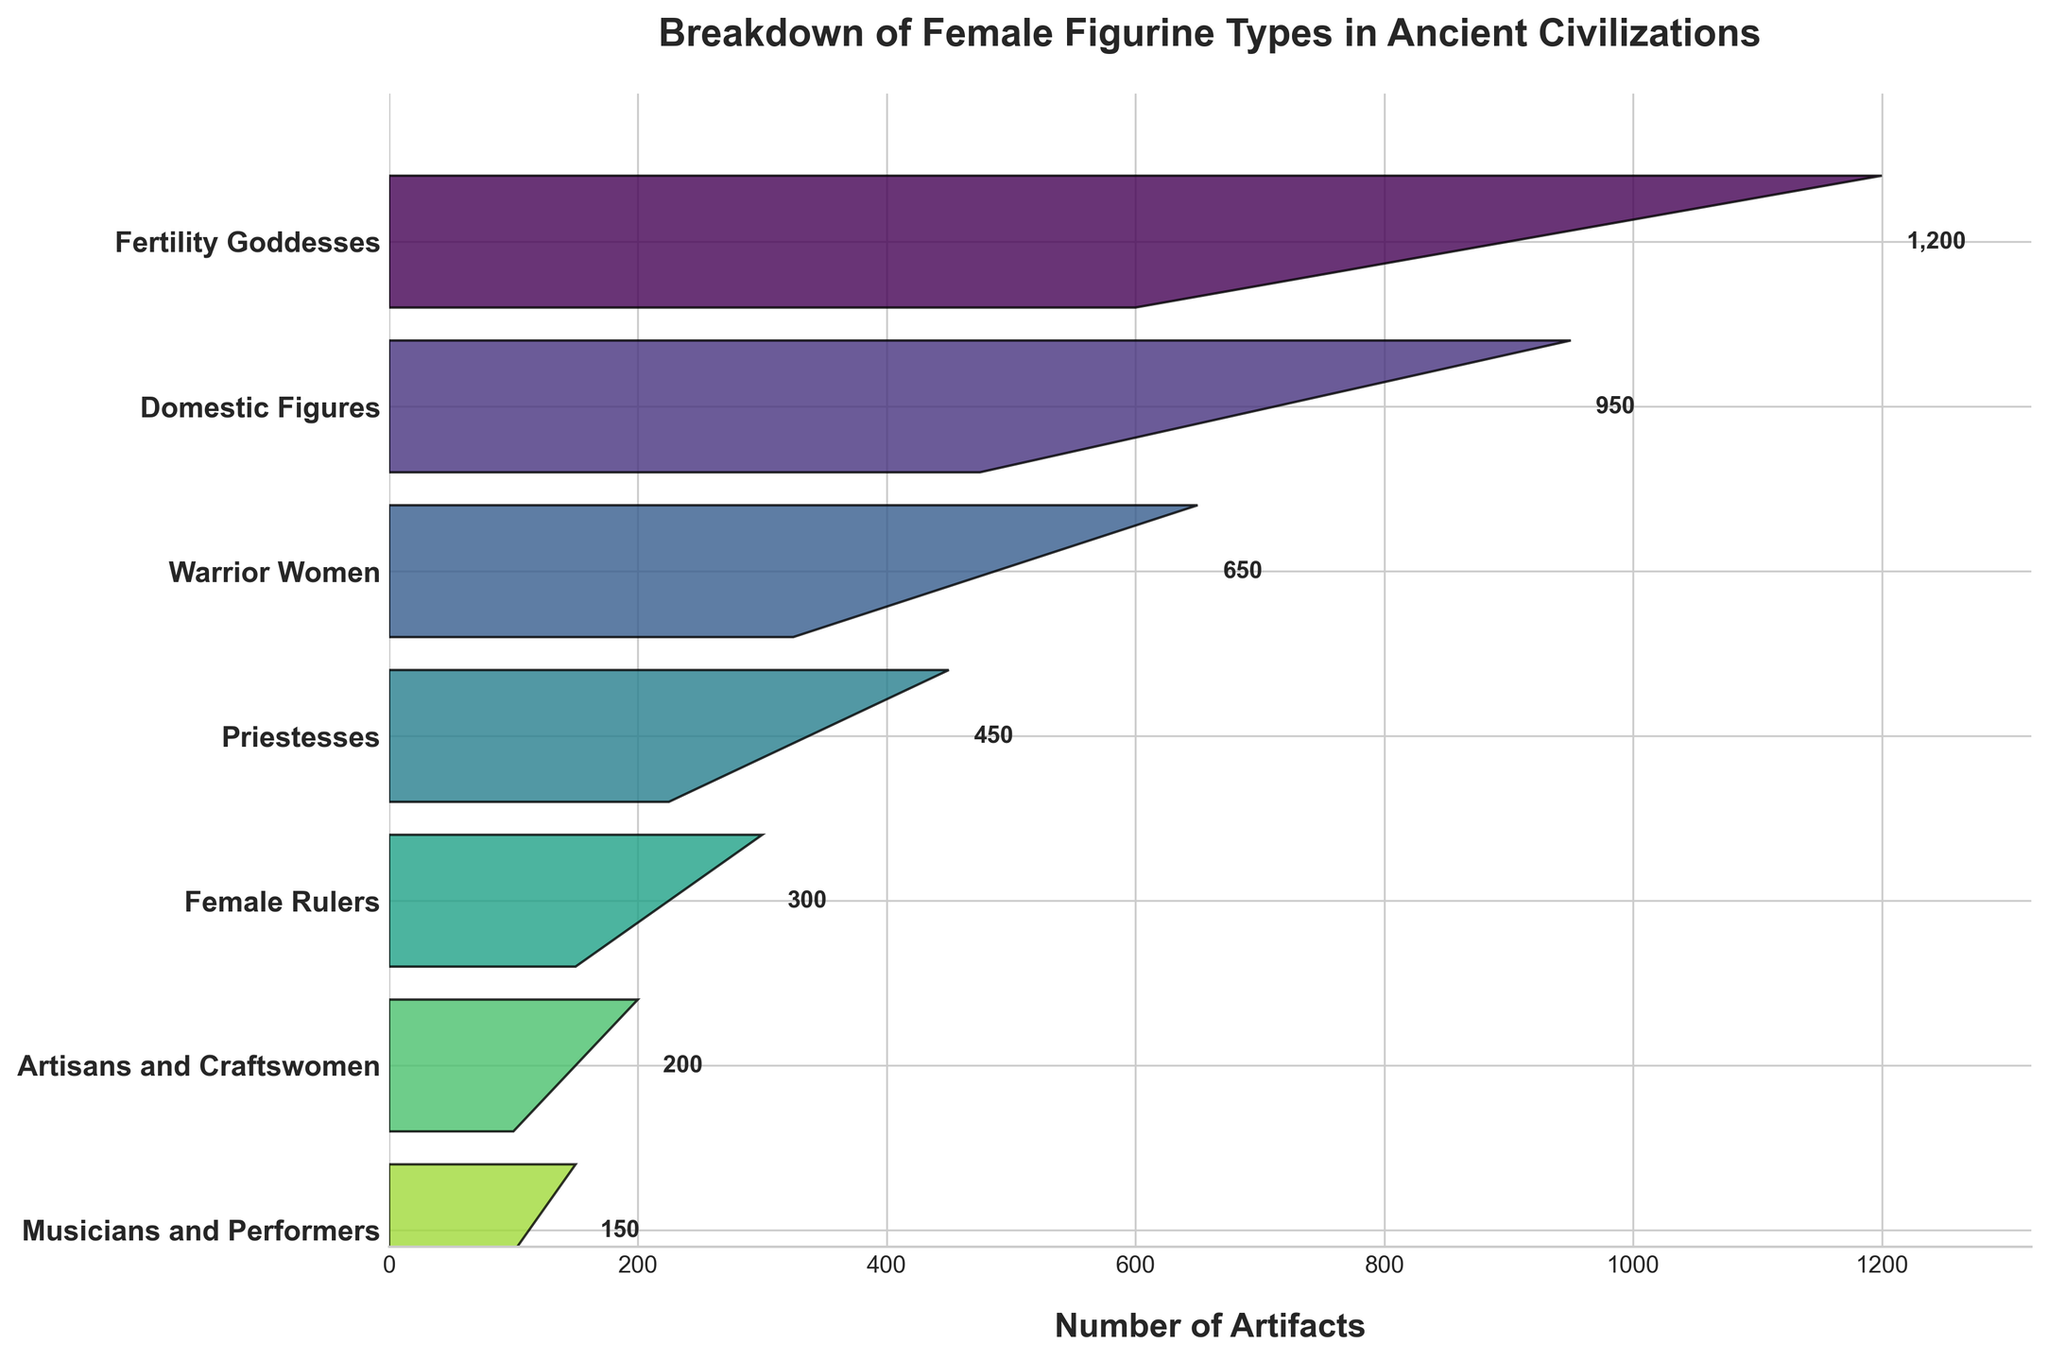What is the title of the chart? The title of the chart is usually prominently displayed at the top of the figure. In this case, it reads "Breakdown of Female Figurine Types in Ancient Civilizations."
Answer: Breakdown of Female Figurine Types in Ancient Civilizations How many different categories of female figurines are displayed in the chart? To find the number of categories, count the different labels listed on the y-axis. There are seven distinct categories: Fertility Goddesses, Domestic Figures, Warrior Women, Priestesses, Female Rulers, Artisans and Craftswomen, and Musicians and Performers.
Answer: 7 Which category has the highest count of female figurines? To determine the category with the highest count, observe the length of the polygons representing each category. The Fertility Goddesses have the highest count with 1200 figurines.
Answer: Fertility Goddesses What is the total number of female figurines represented in the chart? To find the total number, sum the counts for all categories: 1200 (Fertility Goddesses) + 950 (Domestic Figures) + 650 (Warrior Women) + 450 (Priestesses) + 300 (Female Rulers) + 200 (Artisans and Craftswomen) + 150 (Musicians and Performers) = 3900.
Answer: 3900 Which category has the second-lowest count of female figurines? To determine the second-lowest count, order the categories by the counts in ascending order. After Musicians and Performers (150), Artisans and Craftswomen have the next lowest count with 200 figurines.
Answer: Artisans and Craftswomen What is the difference in the number of figurines between Domestic Figures and Warrior Women? To find the difference, subtract the count of Warrior Women from the count of Domestic Figures: 950 (Domestic Figures) - 650 (Warrior Women) = 300.
Answer: 300 How do the counts of Female Rulers and Priestesses compare? Compare the two counts directly: Female Rulers have 300 figurines, while Priestesses have 450. Therefore, Priestesses have more figurines than Female Rulers.
Answer: Priestesses have more What is the average number of figurines across all categories? To find the average, divide the total number of figurines by the number of categories. Total figurines are 3900, and there are 7 categories. So, 3900 / 7 = ~557.14.
Answer: ~557.14 Which category represents approximately 25% of the total number of figurines? To find the category representing approximately 25%, calculate 25% of the total number: 25/100 * 3900 = 975. The count closest to 975 is Domestic Figures with 950 figurines.
Answer: Domestic Figures Is the count of Artisans and Craftswomen more or less than half the count of Fertility Goddesses? Half the count of Fertility Goddesses is 1200 / 2 = 600. The count for Artisans and Craftswomen is 200, which is less than 600.
Answer: Less 